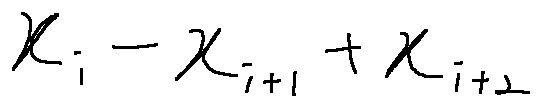Convert formula to latex. <formula><loc_0><loc_0><loc_500><loc_500>x _ { i } - x _ { i + 1 } + x _ { i + 2 }</formula> 